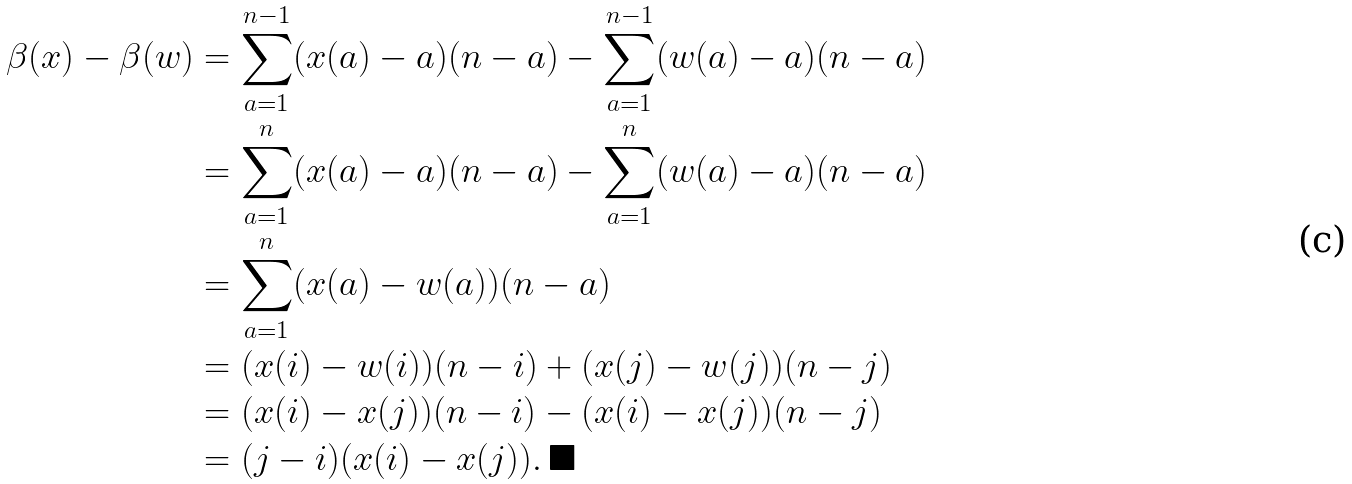<formula> <loc_0><loc_0><loc_500><loc_500>\beta ( x ) - \beta ( w ) & = \sum _ { a = 1 } ^ { n - 1 } ( x ( a ) - a ) ( n - a ) - \sum _ { a = 1 } ^ { n - 1 } ( w ( a ) - a ) ( n - a ) \\ & = \sum _ { a = 1 } ^ { n } ( x ( a ) - a ) ( n - a ) - \sum _ { a = 1 } ^ { n } ( w ( a ) - a ) ( n - a ) \\ & = \sum _ { a = 1 } ^ { n } ( x ( a ) - w ( a ) ) ( n - a ) \\ & = ( x ( i ) - w ( i ) ) ( n - i ) + ( x ( j ) - w ( j ) ) ( n - j ) \\ & = ( x ( i ) - x ( j ) ) ( n - i ) - ( x ( i ) - x ( j ) ) ( n - j ) \\ & = ( j - i ) ( x ( i ) - x ( j ) ) . \, \blacksquare</formula> 